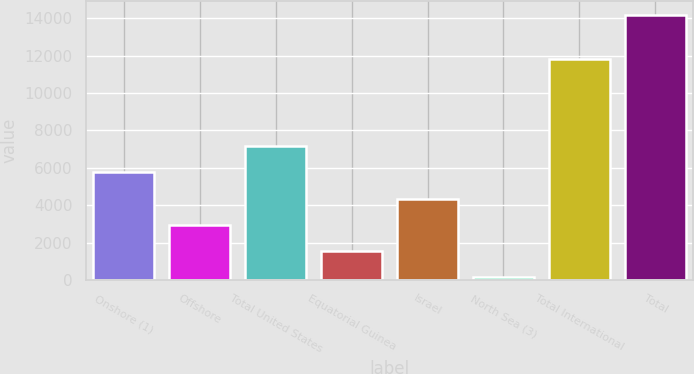<chart> <loc_0><loc_0><loc_500><loc_500><bar_chart><fcel>Onshore (1)<fcel>Offshore<fcel>Total United States<fcel>Equatorial Guinea<fcel>Israel<fcel>North Sea (3)<fcel>Total International<fcel>Total<nl><fcel>5760.6<fcel>2953.8<fcel>7164<fcel>1550.4<fcel>4357.2<fcel>147<fcel>11810<fcel>14181<nl></chart> 